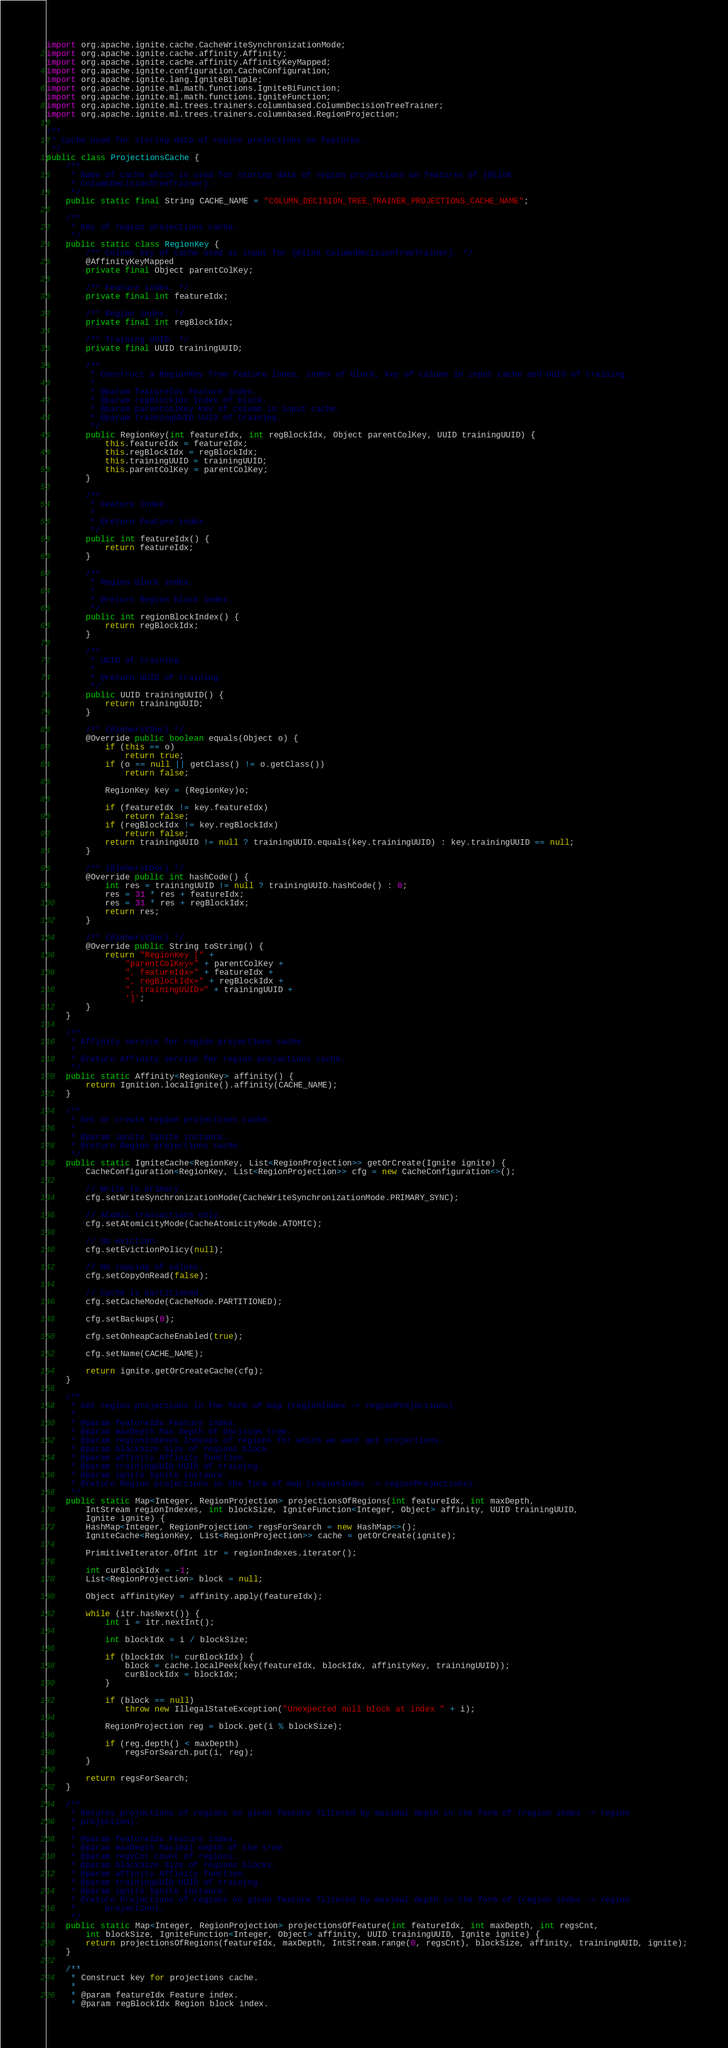<code> <loc_0><loc_0><loc_500><loc_500><_Java_>import org.apache.ignite.cache.CacheWriteSynchronizationMode;
import org.apache.ignite.cache.affinity.Affinity;
import org.apache.ignite.cache.affinity.AffinityKeyMapped;
import org.apache.ignite.configuration.CacheConfiguration;
import org.apache.ignite.lang.IgniteBiTuple;
import org.apache.ignite.ml.math.functions.IgniteBiFunction;
import org.apache.ignite.ml.math.functions.IgniteFunction;
import org.apache.ignite.ml.trees.trainers.columnbased.ColumnDecisionTreeTrainer;
import org.apache.ignite.ml.trees.trainers.columnbased.RegionProjection;

/**
 * Cache used for storing data of region projections on features.
 */
public class ProjectionsCache {
    /**
     * Name of cache which is used for storing data of region projections on features of {@link
     * ColumnDecisionTreeTrainer}.
     */
    public static final String CACHE_NAME = "COLUMN_DECISION_TREE_TRAINER_PROJECTIONS_CACHE_NAME";

    /**
     * Key of region projections cache.
     */
    public static class RegionKey {
        /** Column key of cache used as input for {@link ColumnDecisionTreeTrainer}. */
        @AffinityKeyMapped
        private final Object parentColKey;

        /** Feature index. */
        private final int featureIdx;

        /** Region index. */
        private final int regBlockIdx;

        /** Training UUID. */
        private final UUID trainingUUID;

        /**
         * Construct a RegionKey from feature index, index of block, key of column in input cache and UUID of training.
         *
         * @param featureIdx Feature index.
         * @param regBlockIdx Index of block.
         * @param parentColKey Key of column in input cache.
         * @param trainingUUID UUID of training.
         */
        public RegionKey(int featureIdx, int regBlockIdx, Object parentColKey, UUID trainingUUID) {
            this.featureIdx = featureIdx;
            this.regBlockIdx = regBlockIdx;
            this.trainingUUID = trainingUUID;
            this.parentColKey = parentColKey;
        }

        /**
         * Feature index.
         *
         * @return Feature index.
         */
        public int featureIdx() {
            return featureIdx;
        }

        /**
         * Region block index.
         *
         * @return Region block index.
         */
        public int regionBlockIndex() {
            return regBlockIdx;
        }

        /**
         * UUID of training.
         *
         * @return UUID of training.
         */
        public UUID trainingUUID() {
            return trainingUUID;
        }

        /** {@inheritDoc} */
        @Override public boolean equals(Object o) {
            if (this == o)
                return true;
            if (o == null || getClass() != o.getClass())
                return false;

            RegionKey key = (RegionKey)o;

            if (featureIdx != key.featureIdx)
                return false;
            if (regBlockIdx != key.regBlockIdx)
                return false;
            return trainingUUID != null ? trainingUUID.equals(key.trainingUUID) : key.trainingUUID == null;
        }

        /** {@inheritDoc} */
        @Override public int hashCode() {
            int res = trainingUUID != null ? trainingUUID.hashCode() : 0;
            res = 31 * res + featureIdx;
            res = 31 * res + regBlockIdx;
            return res;
        }

        /** {@inheritDoc} */
        @Override public String toString() {
            return "RegionKey [" +
                "parentColKey=" + parentColKey +
                ", featureIdx=" + featureIdx +
                ", regBlockIdx=" + regBlockIdx +
                ", trainingUUID=" + trainingUUID +
                ']';
        }
    }

    /**
     * Affinity service for region projections cache.
     *
     * @return Affinity service for region projections cache.
     */
    public static Affinity<RegionKey> affinity() {
        return Ignition.localIgnite().affinity(CACHE_NAME);
    }

    /**
     * Get or create region projections cache.
     *
     * @param ignite Ignite instance.
     * @return Region projections cache.
     */
    public static IgniteCache<RegionKey, List<RegionProjection>> getOrCreate(Ignite ignite) {
        CacheConfiguration<RegionKey, List<RegionProjection>> cfg = new CacheConfiguration<>();

        // Write to primary.
        cfg.setWriteSynchronizationMode(CacheWriteSynchronizationMode.PRIMARY_SYNC);

        // Atomic transactions only.
        cfg.setAtomicityMode(CacheAtomicityMode.ATOMIC);

        // No eviction.
        cfg.setEvictionPolicy(null);

        // No copying of values.
        cfg.setCopyOnRead(false);

        // Cache is partitioned.
        cfg.setCacheMode(CacheMode.PARTITIONED);

        cfg.setBackups(0);

        cfg.setOnheapCacheEnabled(true);

        cfg.setName(CACHE_NAME);

        return ignite.getOrCreateCache(cfg);
    }

    /**
     * Get region projections in the form of map (regionIndex -> regionProjections).
     *
     * @param featureIdx Feature index.
     * @param maxDepth Max depth of decision tree.
     * @param regionIndexes Indexes of regions for which we want get projections.
     * @param blockSize Size of regions block.
     * @param affinity Affinity function.
     * @param trainingUUID UUID of training.
     * @param ignite Ignite instance.
     * @return Region projections in the form of map (regionIndex -> regionProjections).
     */
    public static Map<Integer, RegionProjection> projectionsOfRegions(int featureIdx, int maxDepth,
        IntStream regionIndexes, int blockSize, IgniteFunction<Integer, Object> affinity, UUID trainingUUID,
        Ignite ignite) {
        HashMap<Integer, RegionProjection> regsForSearch = new HashMap<>();
        IgniteCache<RegionKey, List<RegionProjection>> cache = getOrCreate(ignite);

        PrimitiveIterator.OfInt itr = regionIndexes.iterator();

        int curBlockIdx = -1;
        List<RegionProjection> block = null;

        Object affinityKey = affinity.apply(featureIdx);

        while (itr.hasNext()) {
            int i = itr.nextInt();

            int blockIdx = i / blockSize;

            if (blockIdx != curBlockIdx) {
                block = cache.localPeek(key(featureIdx, blockIdx, affinityKey, trainingUUID));
                curBlockIdx = blockIdx;
            }

            if (block == null)
                throw new IllegalStateException("Unexpected null block at index " + i);

            RegionProjection reg = block.get(i % blockSize);

            if (reg.depth() < maxDepth)
                regsForSearch.put(i, reg);
        }

        return regsForSearch;
    }

    /**
     * Returns projections of regions on given feature filtered by maximal depth in the form of (region index -> region
     * projection).
     *
     * @param featureIdx Feature index.
     * @param maxDepth Maximal depth of the tree.
     * @param regsCnt Count of regions.
     * @param blockSize Size of regions blocks.
     * @param affinity Affinity function.
     * @param trainingUUID UUID of training.
     * @param ignite Ignite instance.
     * @return Projections of regions on given feature filtered by maximal depth in the form of (region index -> region
     *      projection).
     */
    public static Map<Integer, RegionProjection> projectionsOfFeature(int featureIdx, int maxDepth, int regsCnt,
        int blockSize, IgniteFunction<Integer, Object> affinity, UUID trainingUUID, Ignite ignite) {
        return projectionsOfRegions(featureIdx, maxDepth, IntStream.range(0, regsCnt), blockSize, affinity, trainingUUID, ignite);
    }

    /**
     * Construct key for projections cache.
     *
     * @param featureIdx Feature index.
     * @param regBlockIdx Region block index.</code> 